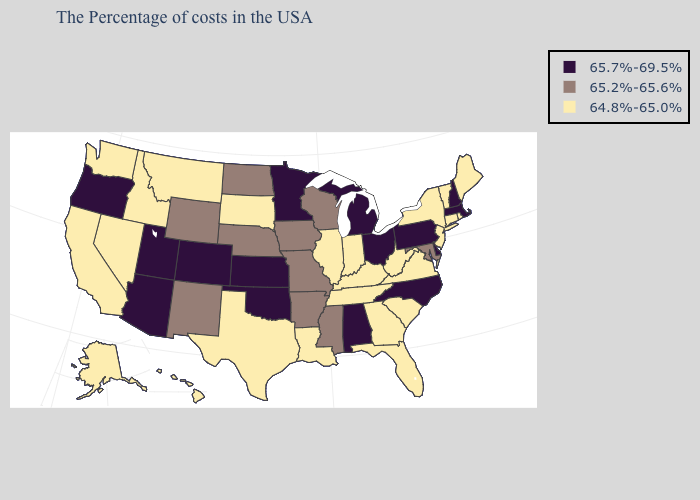Name the states that have a value in the range 65.2%-65.6%?
Short answer required. Maryland, Wisconsin, Mississippi, Missouri, Arkansas, Iowa, Nebraska, North Dakota, Wyoming, New Mexico. Name the states that have a value in the range 65.7%-69.5%?
Keep it brief. Massachusetts, New Hampshire, Delaware, Pennsylvania, North Carolina, Ohio, Michigan, Alabama, Minnesota, Kansas, Oklahoma, Colorado, Utah, Arizona, Oregon. Which states have the highest value in the USA?
Be succinct. Massachusetts, New Hampshire, Delaware, Pennsylvania, North Carolina, Ohio, Michigan, Alabama, Minnesota, Kansas, Oklahoma, Colorado, Utah, Arizona, Oregon. Does the first symbol in the legend represent the smallest category?
Concise answer only. No. Name the states that have a value in the range 65.7%-69.5%?
Write a very short answer. Massachusetts, New Hampshire, Delaware, Pennsylvania, North Carolina, Ohio, Michigan, Alabama, Minnesota, Kansas, Oklahoma, Colorado, Utah, Arizona, Oregon. How many symbols are there in the legend?
Keep it brief. 3. What is the highest value in the South ?
Quick response, please. 65.7%-69.5%. Which states have the lowest value in the USA?
Quick response, please. Maine, Rhode Island, Vermont, Connecticut, New York, New Jersey, Virginia, South Carolina, West Virginia, Florida, Georgia, Kentucky, Indiana, Tennessee, Illinois, Louisiana, Texas, South Dakota, Montana, Idaho, Nevada, California, Washington, Alaska, Hawaii. What is the value of New York?
Short answer required. 64.8%-65.0%. Does Oregon have the lowest value in the USA?
Write a very short answer. No. What is the lowest value in the Northeast?
Answer briefly. 64.8%-65.0%. Among the states that border New Mexico , does Oklahoma have the highest value?
Keep it brief. Yes. What is the lowest value in the South?
Concise answer only. 64.8%-65.0%. Name the states that have a value in the range 64.8%-65.0%?
Give a very brief answer. Maine, Rhode Island, Vermont, Connecticut, New York, New Jersey, Virginia, South Carolina, West Virginia, Florida, Georgia, Kentucky, Indiana, Tennessee, Illinois, Louisiana, Texas, South Dakota, Montana, Idaho, Nevada, California, Washington, Alaska, Hawaii. 